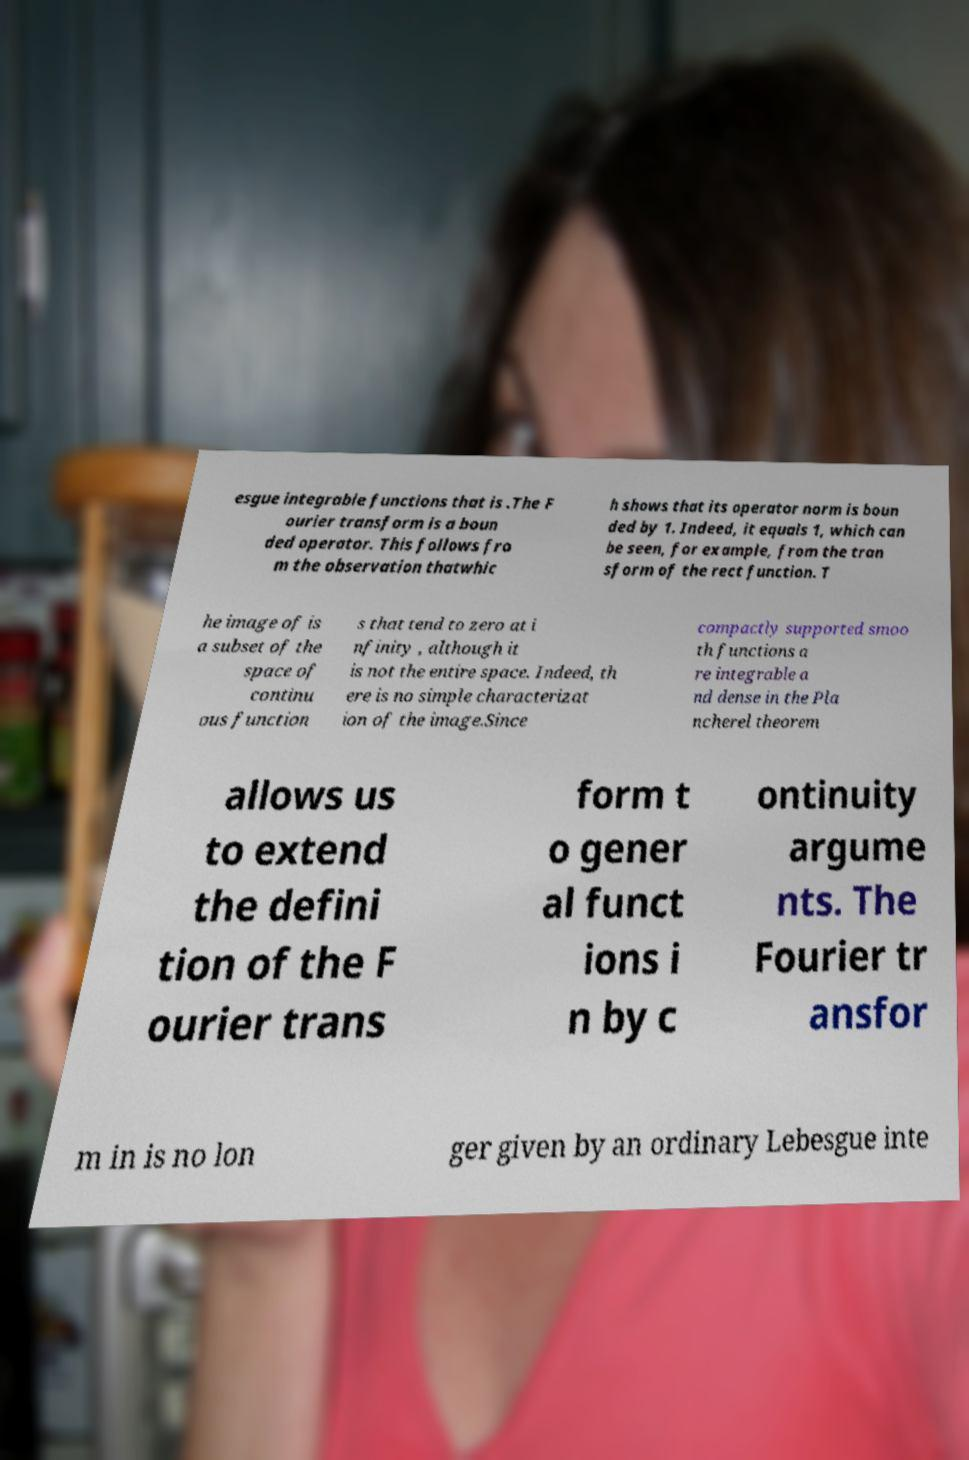Please identify and transcribe the text found in this image. esgue integrable functions that is .The F ourier transform is a boun ded operator. This follows fro m the observation thatwhic h shows that its operator norm is boun ded by 1. Indeed, it equals 1, which can be seen, for example, from the tran sform of the rect function. T he image of is a subset of the space of continu ous function s that tend to zero at i nfinity , although it is not the entire space. Indeed, th ere is no simple characterizat ion of the image.Since compactly supported smoo th functions a re integrable a nd dense in the Pla ncherel theorem allows us to extend the defini tion of the F ourier trans form t o gener al funct ions i n by c ontinuity argume nts. The Fourier tr ansfor m in is no lon ger given by an ordinary Lebesgue inte 